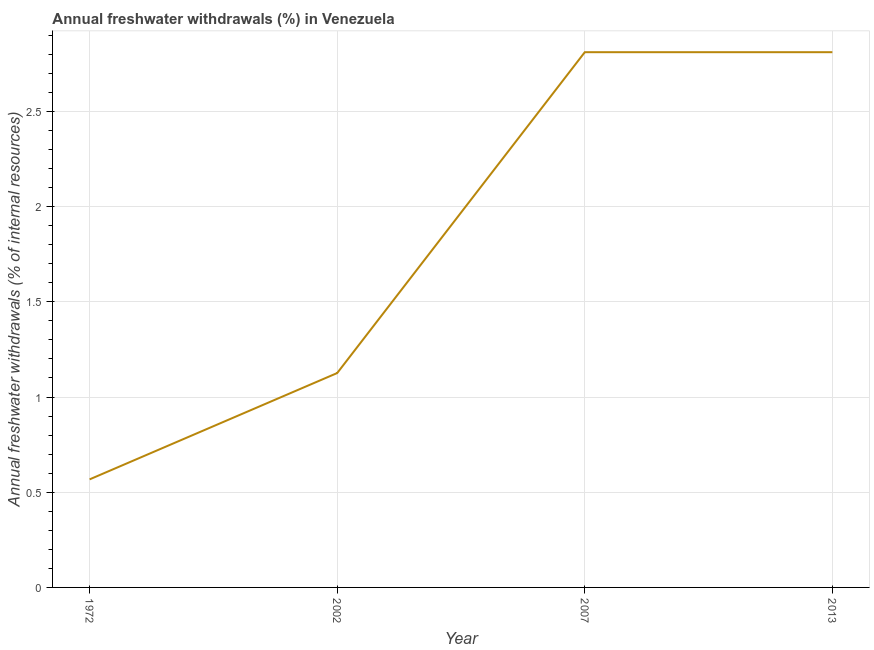What is the annual freshwater withdrawals in 2002?
Ensure brevity in your answer.  1.13. Across all years, what is the maximum annual freshwater withdrawals?
Your answer should be very brief. 2.81. Across all years, what is the minimum annual freshwater withdrawals?
Make the answer very short. 0.57. What is the sum of the annual freshwater withdrawals?
Provide a succinct answer. 7.32. What is the difference between the annual freshwater withdrawals in 2007 and 2013?
Give a very brief answer. 0. What is the average annual freshwater withdrawals per year?
Provide a short and direct response. 1.83. What is the median annual freshwater withdrawals?
Ensure brevity in your answer.  1.97. What is the ratio of the annual freshwater withdrawals in 2002 to that in 2007?
Your answer should be compact. 0.4. Is the difference between the annual freshwater withdrawals in 1972 and 2013 greater than the difference between any two years?
Offer a terse response. Yes. What is the difference between the highest and the second highest annual freshwater withdrawals?
Your response must be concise. 0. What is the difference between the highest and the lowest annual freshwater withdrawals?
Keep it short and to the point. 2.24. How many lines are there?
Your answer should be compact. 1. What is the difference between two consecutive major ticks on the Y-axis?
Offer a very short reply. 0.5. Are the values on the major ticks of Y-axis written in scientific E-notation?
Give a very brief answer. No. Does the graph contain grids?
Your answer should be compact. Yes. What is the title of the graph?
Provide a succinct answer. Annual freshwater withdrawals (%) in Venezuela. What is the label or title of the Y-axis?
Provide a short and direct response. Annual freshwater withdrawals (% of internal resources). What is the Annual freshwater withdrawals (% of internal resources) of 1972?
Offer a very short reply. 0.57. What is the Annual freshwater withdrawals (% of internal resources) in 2002?
Give a very brief answer. 1.13. What is the Annual freshwater withdrawals (% of internal resources) in 2007?
Ensure brevity in your answer.  2.81. What is the Annual freshwater withdrawals (% of internal resources) in 2013?
Offer a very short reply. 2.81. What is the difference between the Annual freshwater withdrawals (% of internal resources) in 1972 and 2002?
Your response must be concise. -0.56. What is the difference between the Annual freshwater withdrawals (% of internal resources) in 1972 and 2007?
Your response must be concise. -2.24. What is the difference between the Annual freshwater withdrawals (% of internal resources) in 1972 and 2013?
Provide a succinct answer. -2.24. What is the difference between the Annual freshwater withdrawals (% of internal resources) in 2002 and 2007?
Give a very brief answer. -1.69. What is the difference between the Annual freshwater withdrawals (% of internal resources) in 2002 and 2013?
Keep it short and to the point. -1.69. What is the ratio of the Annual freshwater withdrawals (% of internal resources) in 1972 to that in 2002?
Offer a terse response. 0.5. What is the ratio of the Annual freshwater withdrawals (% of internal resources) in 1972 to that in 2007?
Your answer should be very brief. 0.2. What is the ratio of the Annual freshwater withdrawals (% of internal resources) in 1972 to that in 2013?
Give a very brief answer. 0.2. What is the ratio of the Annual freshwater withdrawals (% of internal resources) in 2002 to that in 2007?
Ensure brevity in your answer.  0.4. What is the ratio of the Annual freshwater withdrawals (% of internal resources) in 2002 to that in 2013?
Keep it short and to the point. 0.4. What is the ratio of the Annual freshwater withdrawals (% of internal resources) in 2007 to that in 2013?
Your response must be concise. 1. 